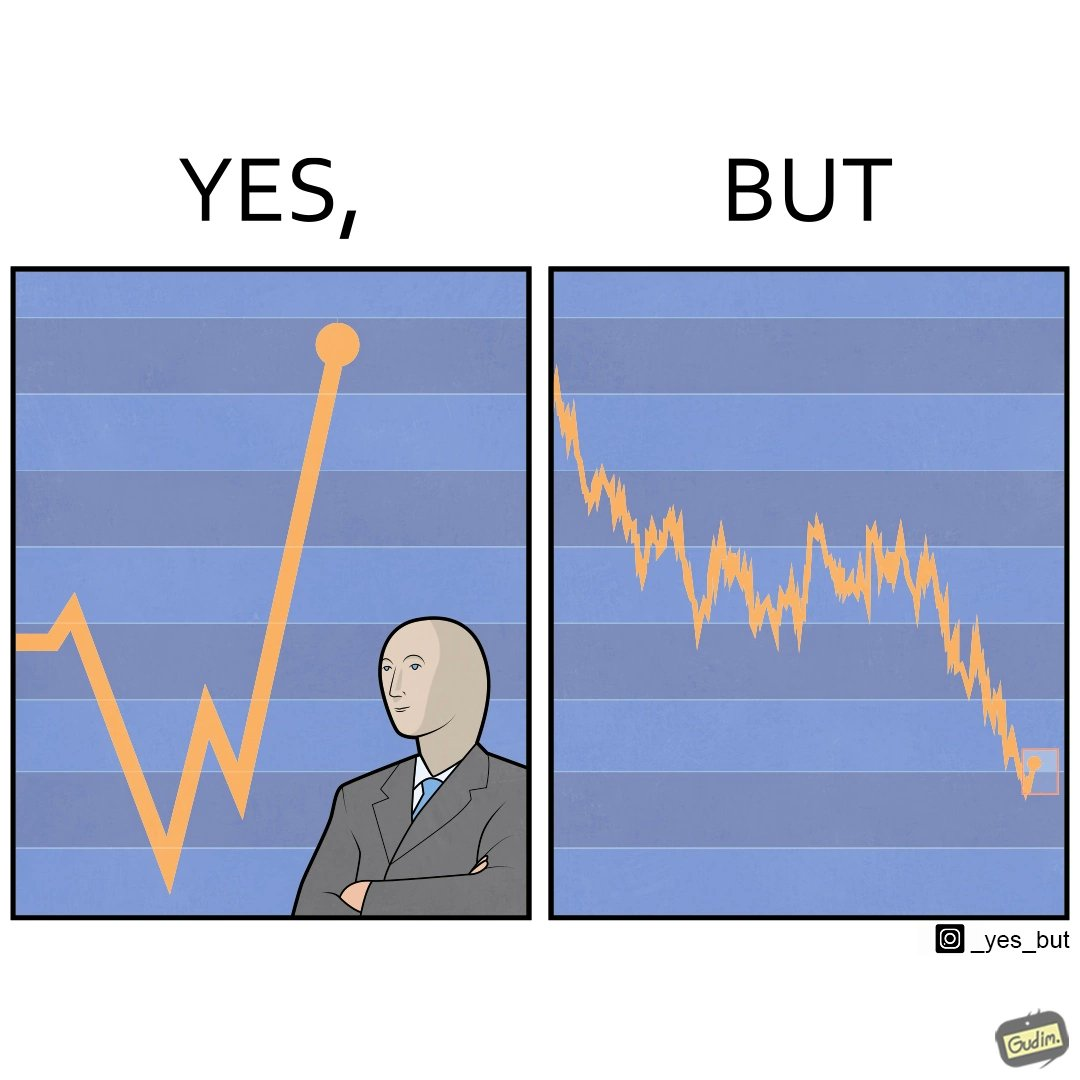Does this image contain satire or humor? Yes, this image is satirical. 